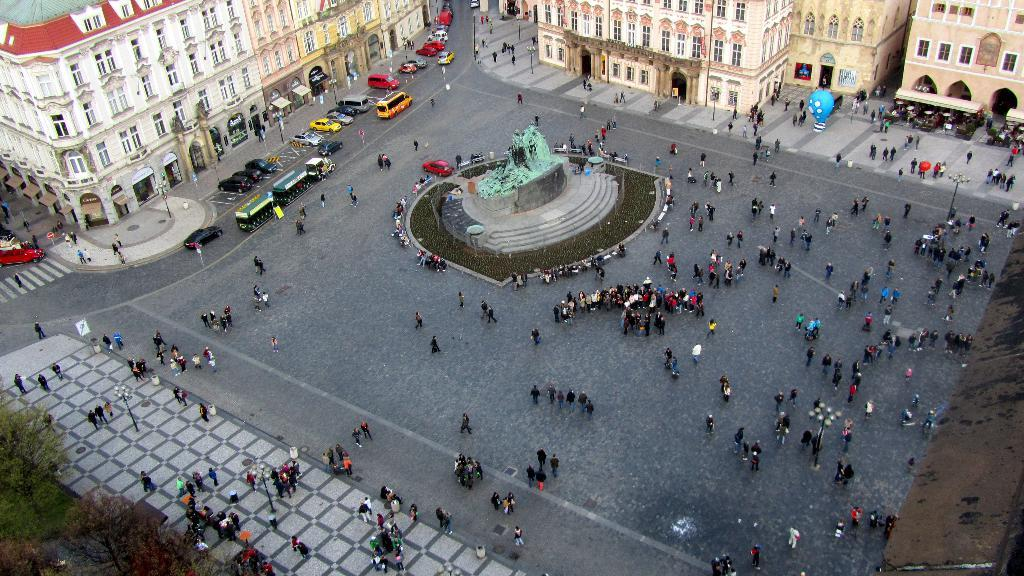How many people are in the image? There is a group of people in the image, but the exact number cannot be determined from the provided facts. What type of structures can be seen in the image? There are buildings in the image. What else can be seen in the image besides the group of people and buildings? There are poles, sign boards, vehicles, and trees in the bottom left corner of the image. What type of cracker is being used to fix the sign boards in the image? There is no cracker present in the image, and no mention of fixing sign boards. How many bears are visible in the image? There are no bears present in the image. 